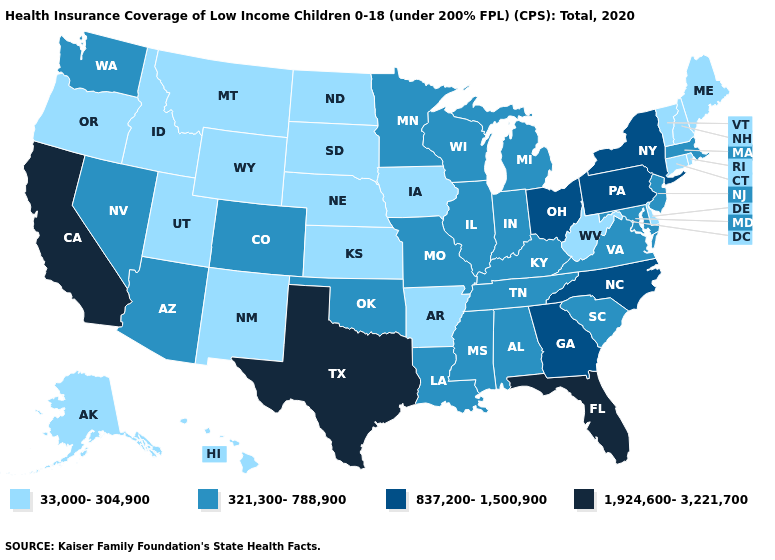Does Texas have the same value as Florida?
Write a very short answer. Yes. Does the map have missing data?
Write a very short answer. No. Name the states that have a value in the range 837,200-1,500,900?
Quick response, please. Georgia, New York, North Carolina, Ohio, Pennsylvania. Does Montana have a higher value than Nebraska?
Answer briefly. No. Does North Dakota have the highest value in the USA?
Short answer required. No. Name the states that have a value in the range 1,924,600-3,221,700?
Quick response, please. California, Florida, Texas. What is the value of Montana?
Concise answer only. 33,000-304,900. Name the states that have a value in the range 33,000-304,900?
Give a very brief answer. Alaska, Arkansas, Connecticut, Delaware, Hawaii, Idaho, Iowa, Kansas, Maine, Montana, Nebraska, New Hampshire, New Mexico, North Dakota, Oregon, Rhode Island, South Dakota, Utah, Vermont, West Virginia, Wyoming. Which states have the highest value in the USA?
Short answer required. California, Florida, Texas. What is the value of Kansas?
Answer briefly. 33,000-304,900. Does Pennsylvania have the lowest value in the USA?
Keep it brief. No. Name the states that have a value in the range 33,000-304,900?
Short answer required. Alaska, Arkansas, Connecticut, Delaware, Hawaii, Idaho, Iowa, Kansas, Maine, Montana, Nebraska, New Hampshire, New Mexico, North Dakota, Oregon, Rhode Island, South Dakota, Utah, Vermont, West Virginia, Wyoming. Name the states that have a value in the range 321,300-788,900?
Short answer required. Alabama, Arizona, Colorado, Illinois, Indiana, Kentucky, Louisiana, Maryland, Massachusetts, Michigan, Minnesota, Mississippi, Missouri, Nevada, New Jersey, Oklahoma, South Carolina, Tennessee, Virginia, Washington, Wisconsin. Does Wyoming have a lower value than Alaska?
Concise answer only. No. 